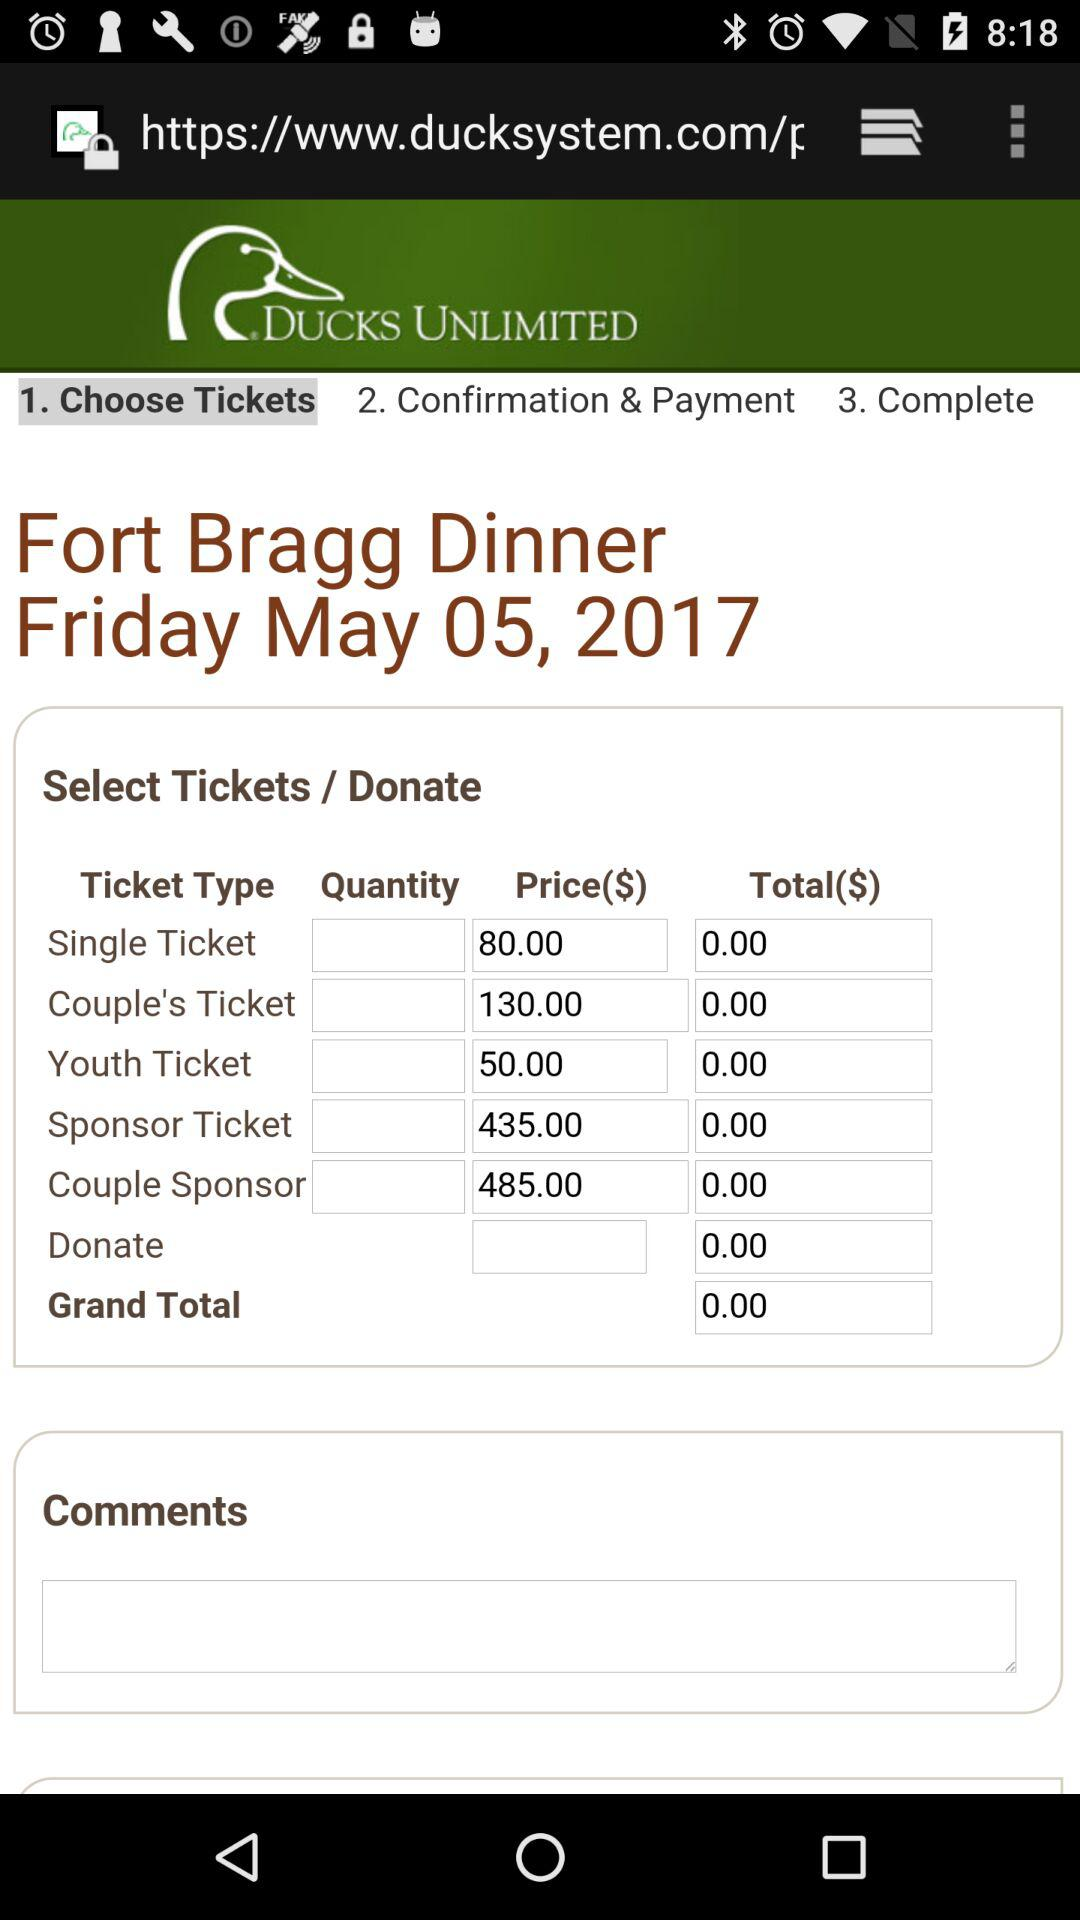What is the price for a "Couple Sponsor Ticket"? The price is $485.00. 